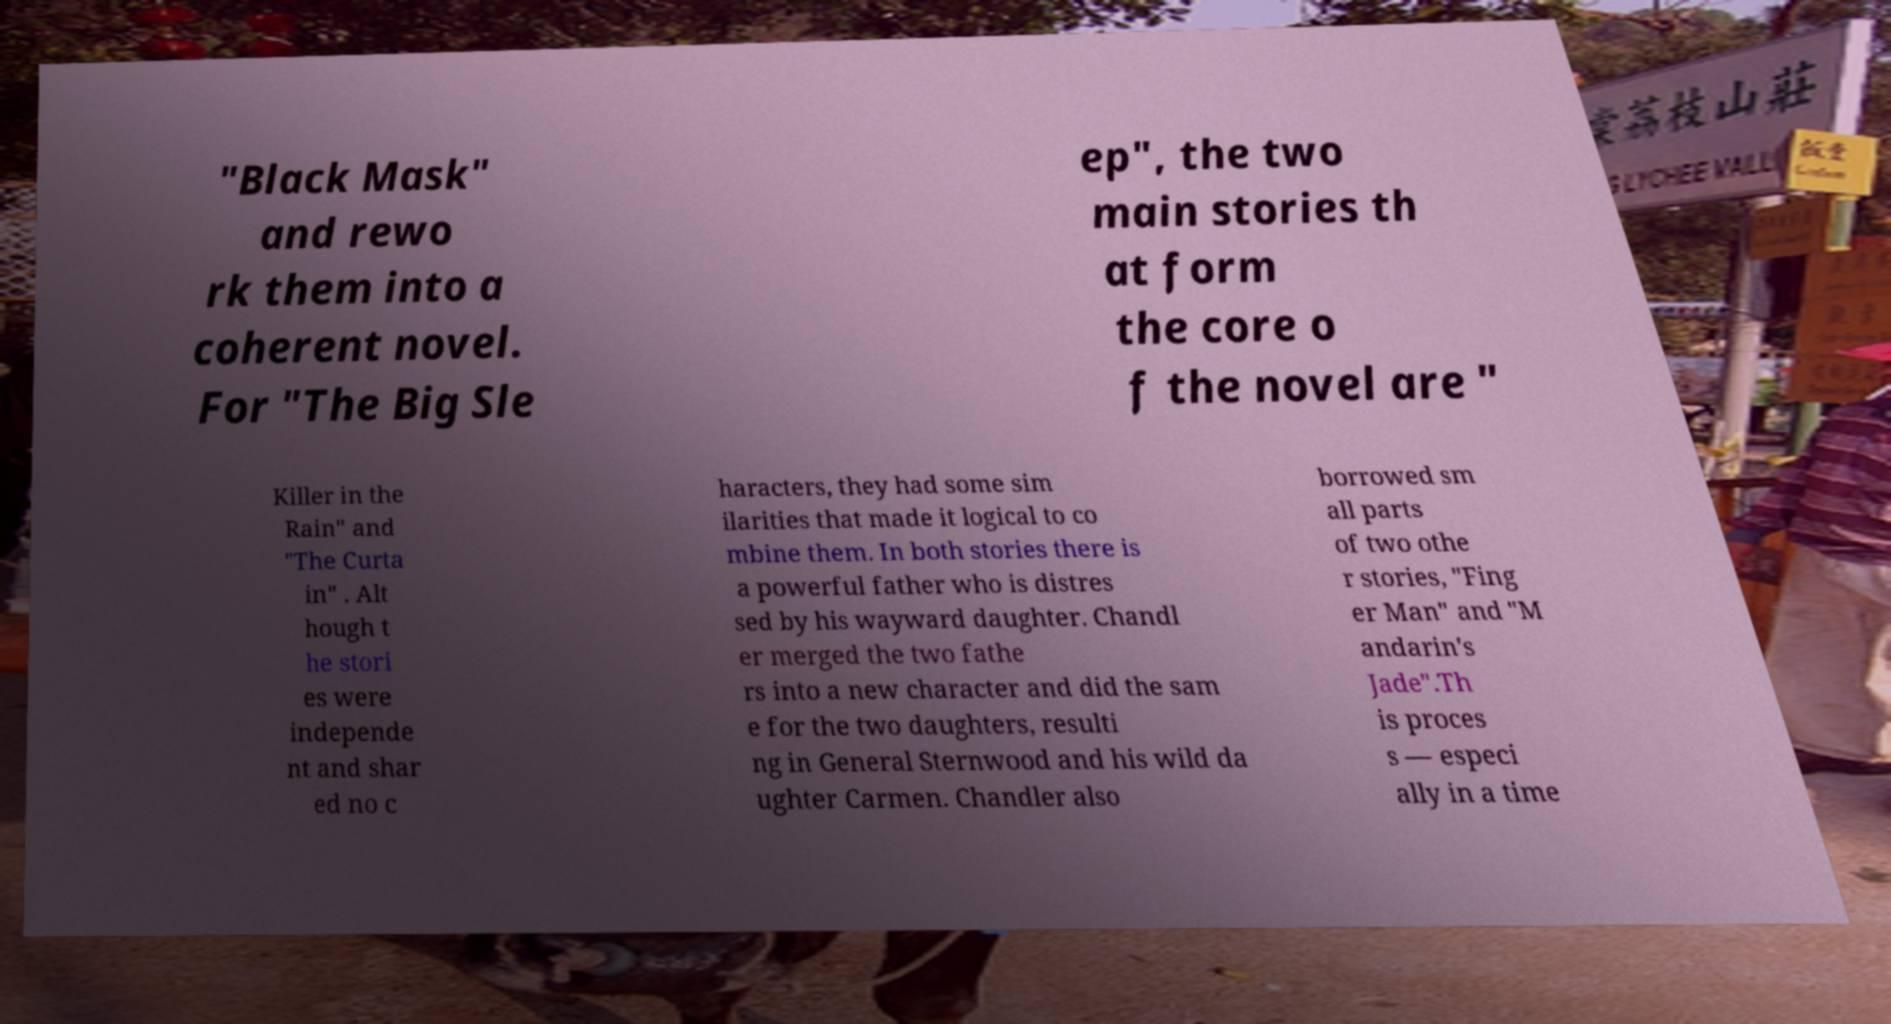What messages or text are displayed in this image? I need them in a readable, typed format. "Black Mask" and rewo rk them into a coherent novel. For "The Big Sle ep", the two main stories th at form the core o f the novel are " Killer in the Rain" and "The Curta in" . Alt hough t he stori es were independe nt and shar ed no c haracters, they had some sim ilarities that made it logical to co mbine them. In both stories there is a powerful father who is distres sed by his wayward daughter. Chandl er merged the two fathe rs into a new character and did the sam e for the two daughters, resulti ng in General Sternwood and his wild da ughter Carmen. Chandler also borrowed sm all parts of two othe r stories, "Fing er Man" and "M andarin's Jade".Th is proces s — especi ally in a time 